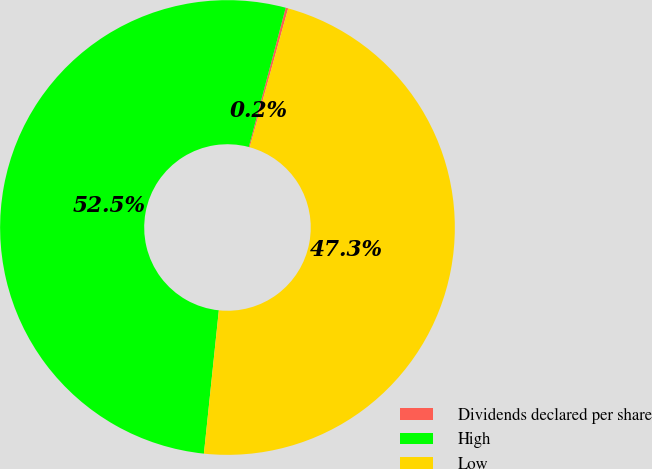<chart> <loc_0><loc_0><loc_500><loc_500><pie_chart><fcel>Dividends declared per share<fcel>High<fcel>Low<nl><fcel>0.18%<fcel>52.47%<fcel>47.35%<nl></chart> 